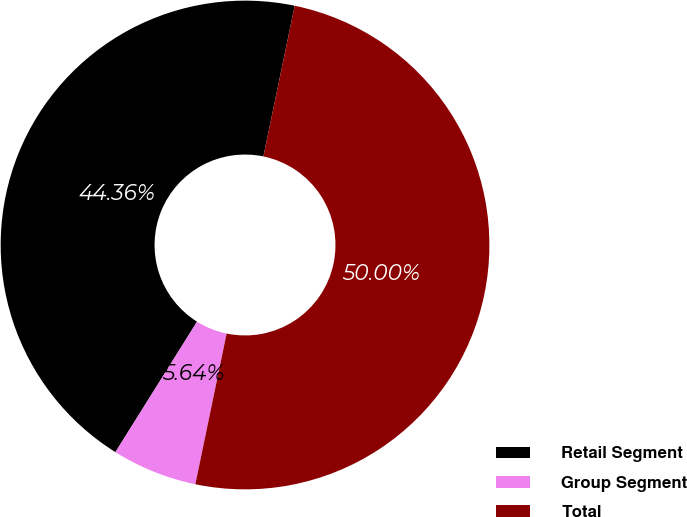Convert chart to OTSL. <chart><loc_0><loc_0><loc_500><loc_500><pie_chart><fcel>Retail Segment<fcel>Group Segment<fcel>Total<nl><fcel>44.36%<fcel>5.64%<fcel>50.0%<nl></chart> 